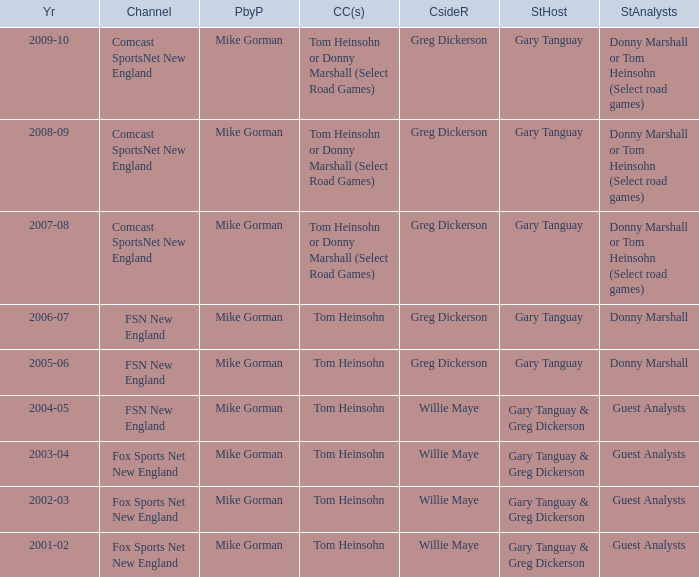Help me parse the entirety of this table. {'header': ['Yr', 'Channel', 'PbyP', 'CC(s)', 'CsideR', 'StHost', 'StAnalysts'], 'rows': [['2009-10', 'Comcast SportsNet New England', 'Mike Gorman', 'Tom Heinsohn or Donny Marshall (Select Road Games)', 'Greg Dickerson', 'Gary Tanguay', 'Donny Marshall or Tom Heinsohn (Select road games)'], ['2008-09', 'Comcast SportsNet New England', 'Mike Gorman', 'Tom Heinsohn or Donny Marshall (Select Road Games)', 'Greg Dickerson', 'Gary Tanguay', 'Donny Marshall or Tom Heinsohn (Select road games)'], ['2007-08', 'Comcast SportsNet New England', 'Mike Gorman', 'Tom Heinsohn or Donny Marshall (Select Road Games)', 'Greg Dickerson', 'Gary Tanguay', 'Donny Marshall or Tom Heinsohn (Select road games)'], ['2006-07', 'FSN New England', 'Mike Gorman', 'Tom Heinsohn', 'Greg Dickerson', 'Gary Tanguay', 'Donny Marshall'], ['2005-06', 'FSN New England', 'Mike Gorman', 'Tom Heinsohn', 'Greg Dickerson', 'Gary Tanguay', 'Donny Marshall'], ['2004-05', 'FSN New England', 'Mike Gorman', 'Tom Heinsohn', 'Willie Maye', 'Gary Tanguay & Greg Dickerson', 'Guest Analysts'], ['2003-04', 'Fox Sports Net New England', 'Mike Gorman', 'Tom Heinsohn', 'Willie Maye', 'Gary Tanguay & Greg Dickerson', 'Guest Analysts'], ['2002-03', 'Fox Sports Net New England', 'Mike Gorman', 'Tom Heinsohn', 'Willie Maye', 'Gary Tanguay & Greg Dickerson', 'Guest Analysts'], ['2001-02', 'Fox Sports Net New England', 'Mike Gorman', 'Tom Heinsohn', 'Willie Maye', 'Gary Tanguay & Greg Dickerson', 'Guest Analysts']]} Who is the studio host for the year 2006-07? Gary Tanguay. 